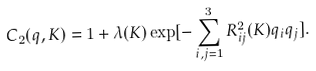Convert formula to latex. <formula><loc_0><loc_0><loc_500><loc_500>C _ { 2 } ( { q , K } ) = 1 + \lambda ( { K } ) \exp [ - \sum _ { i , j = 1 } ^ { 3 } R _ { i j } ^ { 2 } ( { K } ) q _ { i } q _ { j } ] .</formula> 